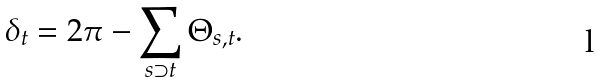Convert formula to latex. <formula><loc_0><loc_0><loc_500><loc_500>\delta _ { t } = 2 \pi - \sum _ { s \supset t } \Theta _ { s , t } .</formula> 